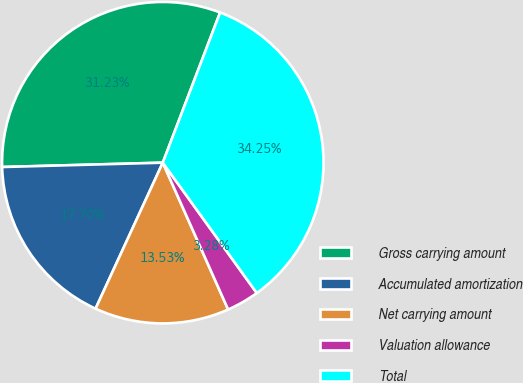Convert chart to OTSL. <chart><loc_0><loc_0><loc_500><loc_500><pie_chart><fcel>Gross carrying amount<fcel>Accumulated amortization<fcel>Net carrying amount<fcel>Valuation allowance<fcel>Total<nl><fcel>31.23%<fcel>17.7%<fcel>13.53%<fcel>3.28%<fcel>34.25%<nl></chart> 